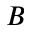Convert formula to latex. <formula><loc_0><loc_0><loc_500><loc_500>B</formula> 